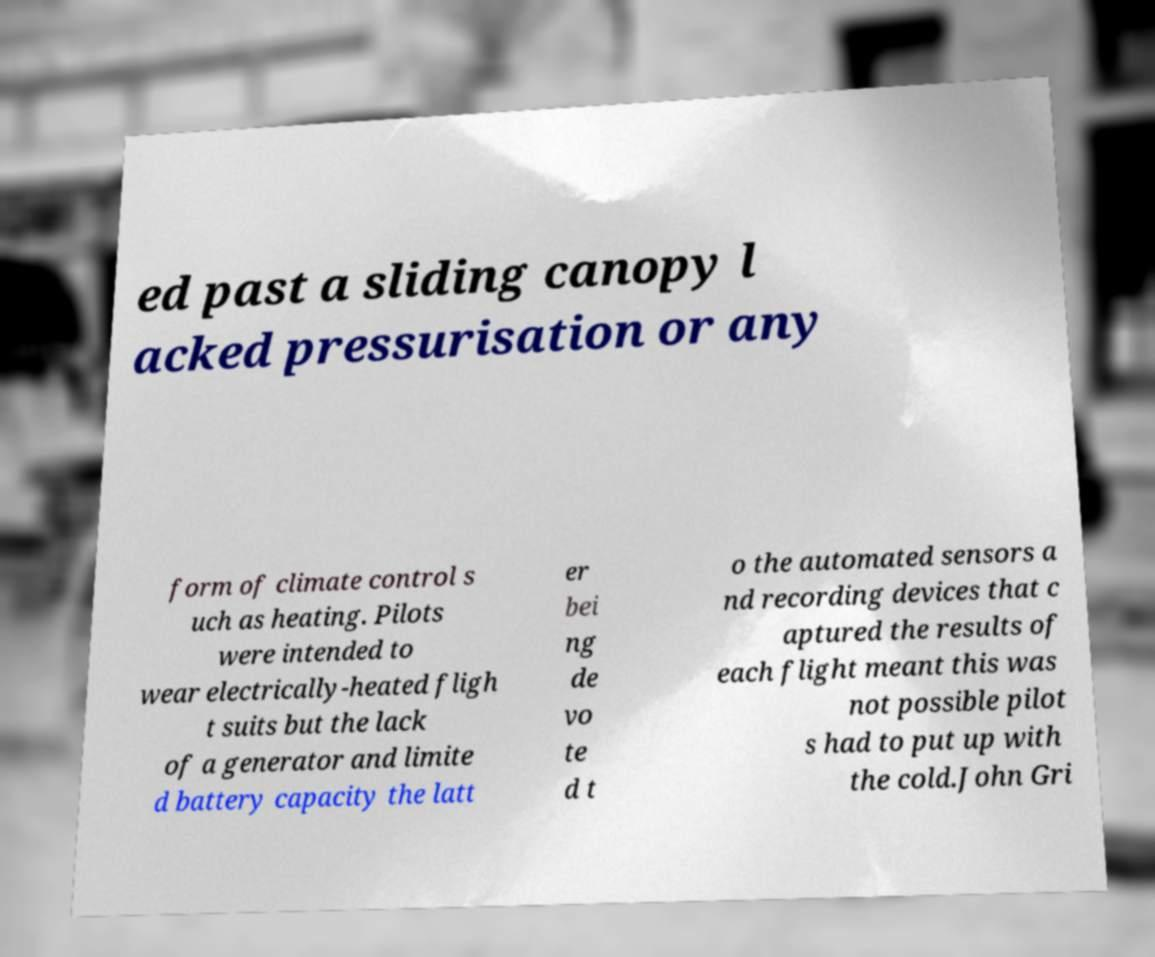Please identify and transcribe the text found in this image. ed past a sliding canopy l acked pressurisation or any form of climate control s uch as heating. Pilots were intended to wear electrically-heated fligh t suits but the lack of a generator and limite d battery capacity the latt er bei ng de vo te d t o the automated sensors a nd recording devices that c aptured the results of each flight meant this was not possible pilot s had to put up with the cold.John Gri 